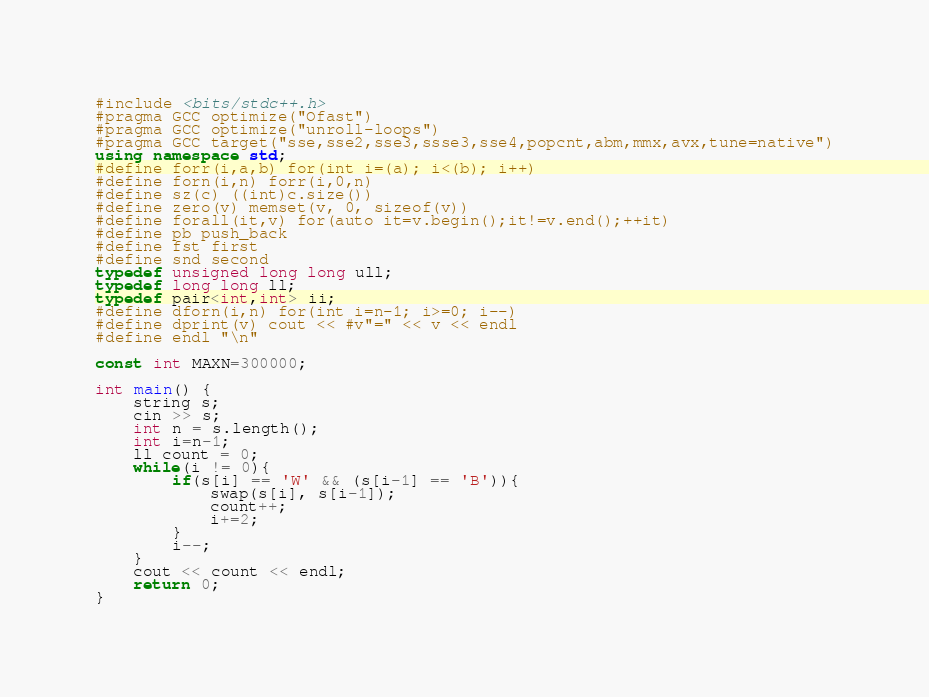Convert code to text. <code><loc_0><loc_0><loc_500><loc_500><_C++_>#include <bits/stdc++.h>
#pragma GCC optimize("Ofast")
#pragma GCC optimize("unroll-loops")
#pragma GCC target("sse,sse2,sse3,ssse3,sse4,popcnt,abm,mmx,avx,tune=native")
using namespace std;
#define forr(i,a,b) for(int i=(a); i<(b); i++)
#define forn(i,n) forr(i,0,n)
#define sz(c) ((int)c.size())
#define zero(v) memset(v, 0, sizeof(v))
#define forall(it,v) for(auto it=v.begin();it!=v.end();++it)
#define pb push_back
#define fst first
#define snd second
typedef unsigned long long ull;
typedef long long ll;
typedef pair<int,int> ii;
#define dforn(i,n) for(int i=n-1; i>=0; i--)
#define dprint(v) cout << #v"=" << v << endl
#define endl "\n"

const int MAXN=300000;

int main() {
    string s;
	cin >> s;
	int n = s.length();
	int i=n-1;
	ll count = 0;
	while(i != 0){
		if(s[i] == 'W' && (s[i-1] == 'B')){
			swap(s[i], s[i-1]);
			count++;
			i+=2;
		}
		i--;
	}	
	cout << count << endl;
	return 0;
}

</code> 